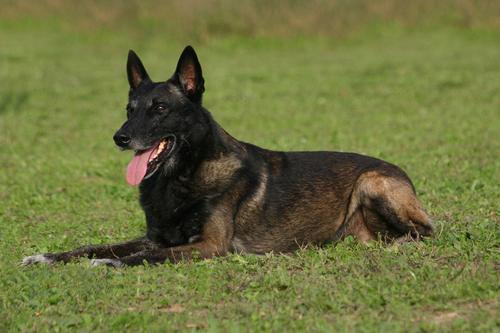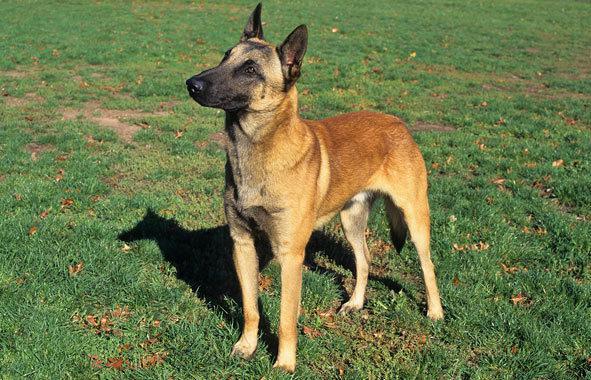The first image is the image on the left, the second image is the image on the right. Evaluate the accuracy of this statement regarding the images: "All the dogs pictured are resting on the grassy ground.". Is it true? Answer yes or no. No. The first image is the image on the left, the second image is the image on the right. For the images shown, is this caption "There is one extended dog tongue in the image on the left." true? Answer yes or no. Yes. 